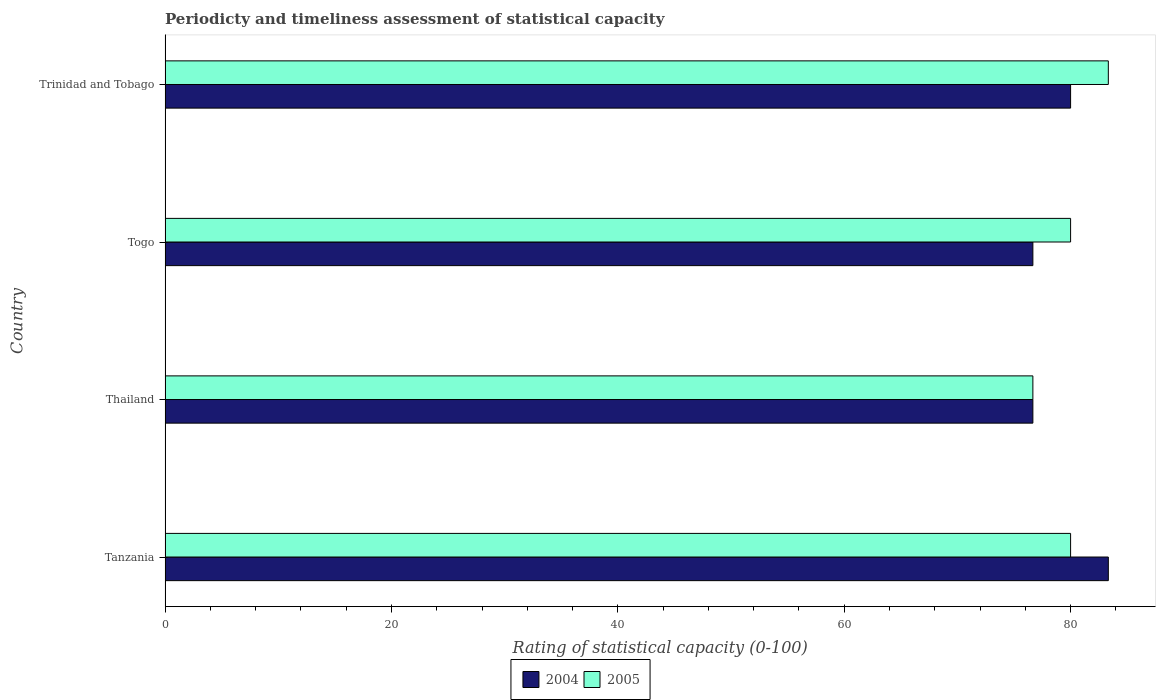How many groups of bars are there?
Provide a succinct answer. 4. Are the number of bars per tick equal to the number of legend labels?
Give a very brief answer. Yes. Are the number of bars on each tick of the Y-axis equal?
Offer a terse response. Yes. What is the label of the 3rd group of bars from the top?
Give a very brief answer. Thailand. In how many cases, is the number of bars for a given country not equal to the number of legend labels?
Give a very brief answer. 0. What is the rating of statistical capacity in 2005 in Thailand?
Offer a terse response. 76.67. Across all countries, what is the maximum rating of statistical capacity in 2005?
Give a very brief answer. 83.33. Across all countries, what is the minimum rating of statistical capacity in 2005?
Make the answer very short. 76.67. In which country was the rating of statistical capacity in 2004 maximum?
Offer a terse response. Tanzania. In which country was the rating of statistical capacity in 2004 minimum?
Keep it short and to the point. Thailand. What is the total rating of statistical capacity in 2004 in the graph?
Provide a succinct answer. 316.67. What is the difference between the rating of statistical capacity in 2005 in Trinidad and Tobago and the rating of statistical capacity in 2004 in Thailand?
Give a very brief answer. 6.67. What is the average rating of statistical capacity in 2004 per country?
Provide a short and direct response. 79.17. What is the difference between the rating of statistical capacity in 2004 and rating of statistical capacity in 2005 in Tanzania?
Offer a terse response. 3.33. What is the ratio of the rating of statistical capacity in 2005 in Tanzania to that in Trinidad and Tobago?
Your answer should be compact. 0.96. Is the rating of statistical capacity in 2004 in Tanzania less than that in Thailand?
Provide a short and direct response. No. Is the difference between the rating of statistical capacity in 2004 in Thailand and Trinidad and Tobago greater than the difference between the rating of statistical capacity in 2005 in Thailand and Trinidad and Tobago?
Your answer should be compact. Yes. What is the difference between the highest and the second highest rating of statistical capacity in 2004?
Provide a short and direct response. 3.33. What is the difference between the highest and the lowest rating of statistical capacity in 2005?
Offer a very short reply. 6.67. What does the 2nd bar from the bottom in Thailand represents?
Your answer should be very brief. 2005. Are all the bars in the graph horizontal?
Give a very brief answer. Yes. What is the difference between two consecutive major ticks on the X-axis?
Your answer should be compact. 20. Are the values on the major ticks of X-axis written in scientific E-notation?
Offer a very short reply. No. Does the graph contain grids?
Offer a terse response. No. Where does the legend appear in the graph?
Make the answer very short. Bottom center. How many legend labels are there?
Your answer should be very brief. 2. What is the title of the graph?
Provide a short and direct response. Periodicty and timeliness assessment of statistical capacity. What is the label or title of the X-axis?
Offer a terse response. Rating of statistical capacity (0-100). What is the label or title of the Y-axis?
Your answer should be very brief. Country. What is the Rating of statistical capacity (0-100) of 2004 in Tanzania?
Give a very brief answer. 83.33. What is the Rating of statistical capacity (0-100) in 2004 in Thailand?
Keep it short and to the point. 76.67. What is the Rating of statistical capacity (0-100) of 2005 in Thailand?
Give a very brief answer. 76.67. What is the Rating of statistical capacity (0-100) in 2004 in Togo?
Make the answer very short. 76.67. What is the Rating of statistical capacity (0-100) of 2005 in Togo?
Give a very brief answer. 80. What is the Rating of statistical capacity (0-100) in 2004 in Trinidad and Tobago?
Provide a succinct answer. 80. What is the Rating of statistical capacity (0-100) in 2005 in Trinidad and Tobago?
Your answer should be very brief. 83.33. Across all countries, what is the maximum Rating of statistical capacity (0-100) of 2004?
Your answer should be very brief. 83.33. Across all countries, what is the maximum Rating of statistical capacity (0-100) in 2005?
Your response must be concise. 83.33. Across all countries, what is the minimum Rating of statistical capacity (0-100) in 2004?
Provide a succinct answer. 76.67. Across all countries, what is the minimum Rating of statistical capacity (0-100) in 2005?
Ensure brevity in your answer.  76.67. What is the total Rating of statistical capacity (0-100) of 2004 in the graph?
Provide a succinct answer. 316.67. What is the total Rating of statistical capacity (0-100) of 2005 in the graph?
Offer a terse response. 320. What is the difference between the Rating of statistical capacity (0-100) in 2005 in Tanzania and that in Thailand?
Your answer should be compact. 3.33. What is the difference between the Rating of statistical capacity (0-100) in 2005 in Tanzania and that in Togo?
Your answer should be compact. 0. What is the difference between the Rating of statistical capacity (0-100) in 2005 in Tanzania and that in Trinidad and Tobago?
Provide a succinct answer. -3.33. What is the difference between the Rating of statistical capacity (0-100) of 2005 in Thailand and that in Togo?
Give a very brief answer. -3.33. What is the difference between the Rating of statistical capacity (0-100) of 2005 in Thailand and that in Trinidad and Tobago?
Your answer should be compact. -6.67. What is the difference between the Rating of statistical capacity (0-100) in 2005 in Togo and that in Trinidad and Tobago?
Offer a very short reply. -3.33. What is the difference between the Rating of statistical capacity (0-100) in 2004 in Tanzania and the Rating of statistical capacity (0-100) in 2005 in Thailand?
Ensure brevity in your answer.  6.67. What is the difference between the Rating of statistical capacity (0-100) in 2004 in Tanzania and the Rating of statistical capacity (0-100) in 2005 in Trinidad and Tobago?
Keep it short and to the point. 0. What is the difference between the Rating of statistical capacity (0-100) of 2004 in Thailand and the Rating of statistical capacity (0-100) of 2005 in Togo?
Provide a short and direct response. -3.33. What is the difference between the Rating of statistical capacity (0-100) in 2004 in Thailand and the Rating of statistical capacity (0-100) in 2005 in Trinidad and Tobago?
Your answer should be compact. -6.67. What is the difference between the Rating of statistical capacity (0-100) in 2004 in Togo and the Rating of statistical capacity (0-100) in 2005 in Trinidad and Tobago?
Offer a terse response. -6.67. What is the average Rating of statistical capacity (0-100) of 2004 per country?
Your response must be concise. 79.17. What is the difference between the Rating of statistical capacity (0-100) of 2004 and Rating of statistical capacity (0-100) of 2005 in Tanzania?
Provide a succinct answer. 3.33. What is the difference between the Rating of statistical capacity (0-100) in 2004 and Rating of statistical capacity (0-100) in 2005 in Thailand?
Make the answer very short. 0. What is the difference between the Rating of statistical capacity (0-100) in 2004 and Rating of statistical capacity (0-100) in 2005 in Togo?
Your answer should be very brief. -3.33. What is the difference between the Rating of statistical capacity (0-100) of 2004 and Rating of statistical capacity (0-100) of 2005 in Trinidad and Tobago?
Provide a short and direct response. -3.33. What is the ratio of the Rating of statistical capacity (0-100) in 2004 in Tanzania to that in Thailand?
Make the answer very short. 1.09. What is the ratio of the Rating of statistical capacity (0-100) in 2005 in Tanzania to that in Thailand?
Provide a succinct answer. 1.04. What is the ratio of the Rating of statistical capacity (0-100) of 2004 in Tanzania to that in Togo?
Offer a terse response. 1.09. What is the ratio of the Rating of statistical capacity (0-100) of 2004 in Tanzania to that in Trinidad and Tobago?
Keep it short and to the point. 1.04. What is the ratio of the Rating of statistical capacity (0-100) of 2005 in Tanzania to that in Trinidad and Tobago?
Your answer should be very brief. 0.96. What is the ratio of the Rating of statistical capacity (0-100) in 2004 in Thailand to that in Togo?
Give a very brief answer. 1. What is the ratio of the Rating of statistical capacity (0-100) of 2005 in Thailand to that in Togo?
Ensure brevity in your answer.  0.96. What is the ratio of the Rating of statistical capacity (0-100) of 2004 in Thailand to that in Trinidad and Tobago?
Offer a very short reply. 0.96. What is the ratio of the Rating of statistical capacity (0-100) in 2005 in Thailand to that in Trinidad and Tobago?
Ensure brevity in your answer.  0.92. What is the ratio of the Rating of statistical capacity (0-100) in 2004 in Togo to that in Trinidad and Tobago?
Provide a short and direct response. 0.96. What is the difference between the highest and the second highest Rating of statistical capacity (0-100) in 2005?
Your response must be concise. 3.33. What is the difference between the highest and the lowest Rating of statistical capacity (0-100) of 2004?
Your answer should be very brief. 6.67. 